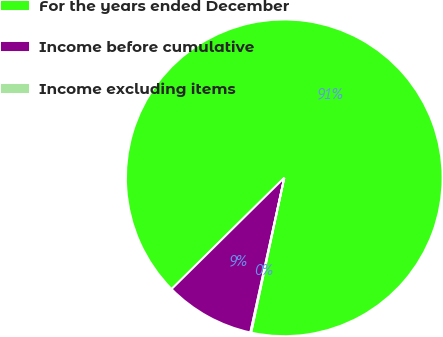<chart> <loc_0><loc_0><loc_500><loc_500><pie_chart><fcel>For the years ended December<fcel>Income before cumulative<fcel>Income excluding items<nl><fcel>90.75%<fcel>9.16%<fcel>0.09%<nl></chart> 